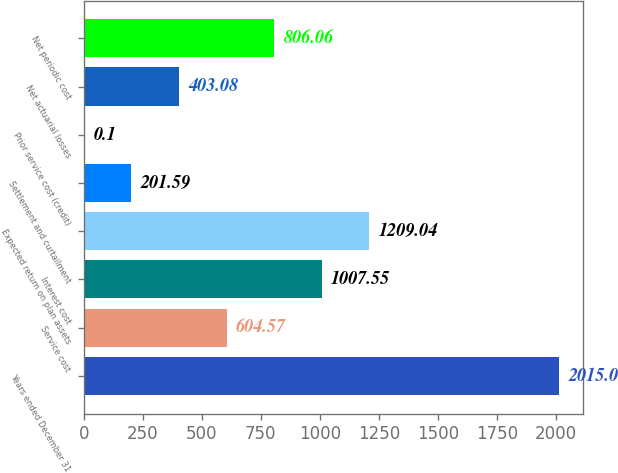Convert chart. <chart><loc_0><loc_0><loc_500><loc_500><bar_chart><fcel>Years ended December 31<fcel>Service cost<fcel>Interest cost<fcel>Expected return on plan assets<fcel>Settlement and curtailment<fcel>Prior service cost (credit)<fcel>Net actuarial losses<fcel>Net periodic cost<nl><fcel>2015<fcel>604.57<fcel>1007.55<fcel>1209.04<fcel>201.59<fcel>0.1<fcel>403.08<fcel>806.06<nl></chart> 